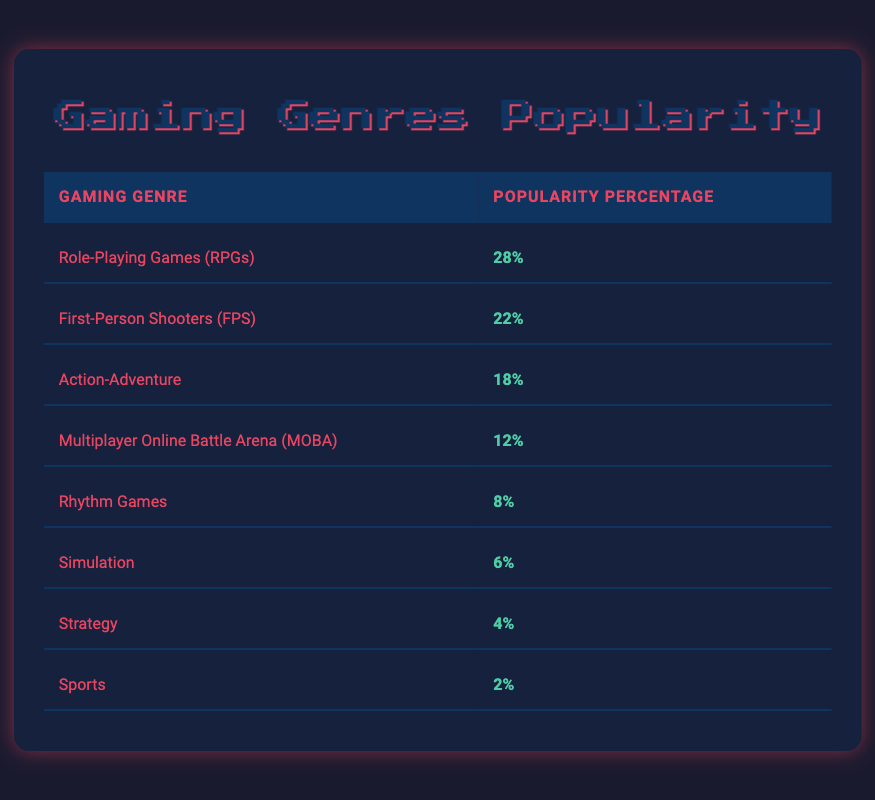What is the most popular gaming genre among community members? The highest value in the "Popularity Percentage" column is 28%, which corresponds to "Role-Playing Games (RPGs)." Hence, this is the most popular genre.
Answer: Role-Playing Games (RPGs) What percentage of community members prefer First-Person Shooters (FPS)? The table lists the popularity percentage for "First-Person Shooters (FPS)" as 22%.
Answer: 22% How many genres have a popularity percentage of 10% or higher? By reviewing the table, the genres with 10% or higher are RPGs (28%), FPS (22%), Action-Adventure (18%), and MOBA (12%). That makes a total of four genres.
Answer: 4 What is the difference in popularity percentage between Action-Adventure and Rhythm Games? "Action-Adventure" has a popularity percentage of 18%, while "Rhythm Games" has 8%. The difference is 18% - 8% = 10%.
Answer: 10% True or False: Simulation games are more popular than Sports games in the community. "Simulation" has a popularity percentage of 6%, and "Sports" has 2%. Since 6% is greater than 2%, it is true that Simulation games are more popular.
Answer: True What is the sum of the popularity percentages of the least popular genres: Strategy and Sports? The popularity of "Strategy" is 4% and "Sports" is 2%. Therefore, the sum is 4% + 2% = 6%.
Answer: 6% Which genre has the least popularity among community members? "Sports" has the lowest percentage in the table at 2%.
Answer: Sports What is the average popularity percentage of all genres listed? To find the average, first sum all the popularity percentages: 28% + 22% + 18% + 12% + 8% + 6% + 4% + 2% = 100%. There are 8 genres, so the average is 100% / 8 = 12.5%.
Answer: 12.5% How do the popularity percentages of RPGs and FPS compare to the total representation of the top three genres? The top three genres are RPGs (28%), FPS (22%), and Action-Adventure (18%). Their total is 28% + 22% + 18% = 68%, which indicates they represent a significant portion of the community preferences. Thus, their combined representation is noteworthy.
Answer: 68% 